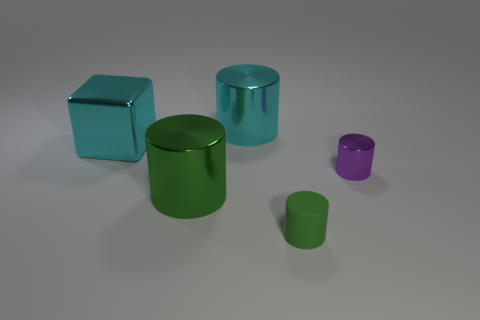What number of other things are there of the same material as the big cyan block
Offer a terse response. 3. Are there any other things that are the same shape as the small green rubber thing?
Ensure brevity in your answer.  Yes. Is the number of tiny purple shiny things left of the small purple metal thing the same as the number of large cyan metal objects that are right of the large cube?
Your answer should be compact. No. There is a block that is made of the same material as the small purple cylinder; what color is it?
Give a very brief answer. Cyan. Does the big green cylinder have the same material as the cyan thing left of the large cyan metallic cylinder?
Keep it short and to the point. Yes. There is a cylinder that is both in front of the small purple metal cylinder and behind the green rubber cylinder; what color is it?
Your response must be concise. Green. How many balls are either yellow rubber objects or big metallic things?
Ensure brevity in your answer.  0. There is a purple thing; is it the same shape as the small thing in front of the tiny purple cylinder?
Offer a very short reply. Yes. How big is the metallic cylinder that is both on the left side of the small purple thing and in front of the cyan cylinder?
Offer a very short reply. Large. What is the shape of the tiny green matte object?
Your response must be concise. Cylinder. 